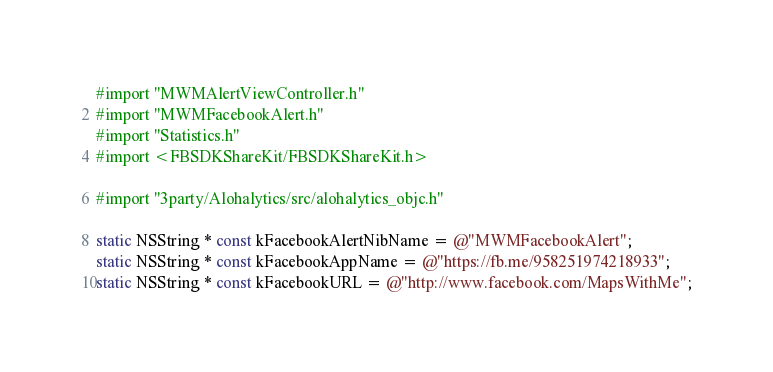Convert code to text. <code><loc_0><loc_0><loc_500><loc_500><_ObjectiveC_>#import "MWMAlertViewController.h"
#import "MWMFacebookAlert.h"
#import "Statistics.h"
#import <FBSDKShareKit/FBSDKShareKit.h>

#import "3party/Alohalytics/src/alohalytics_objc.h"

static NSString * const kFacebookAlertNibName = @"MWMFacebookAlert";
static NSString * const kFacebookAppName = @"https://fb.me/958251974218933";
static NSString * const kFacebookURL = @"http://www.facebook.com/MapsWithMe";</code> 